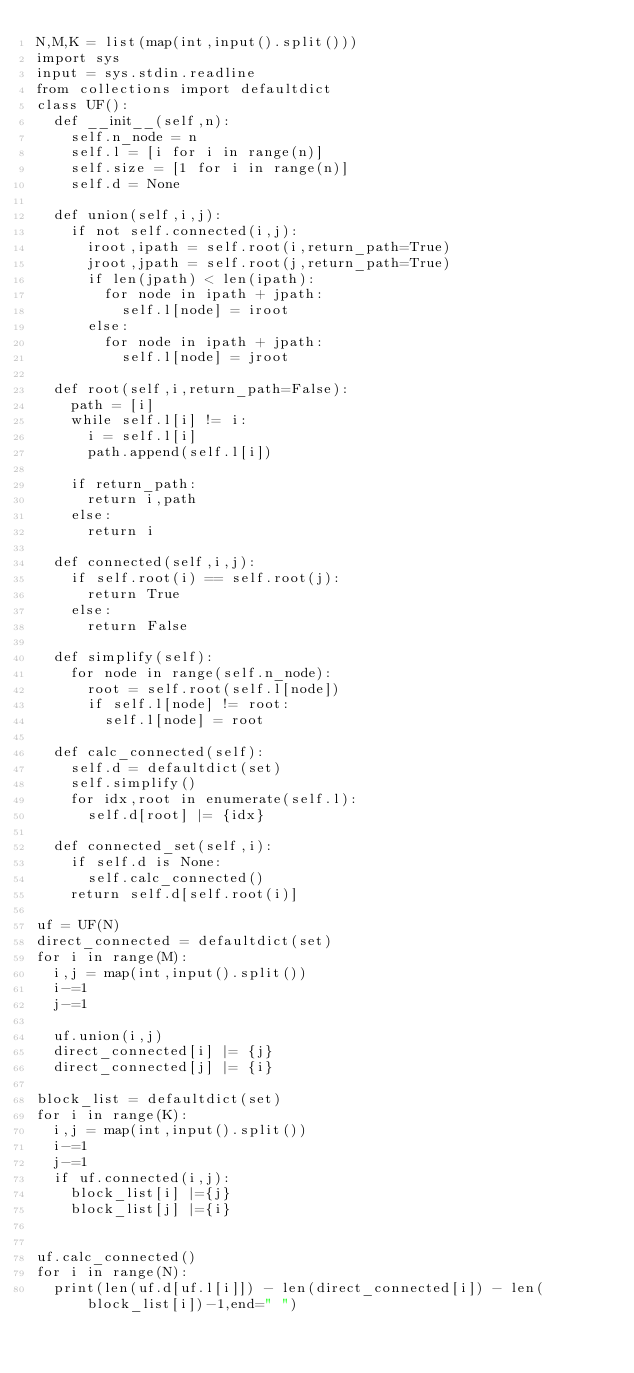<code> <loc_0><loc_0><loc_500><loc_500><_Python_>N,M,K = list(map(int,input().split()))
import sys
input = sys.stdin.readline
from collections import defaultdict
class UF():
  def __init__(self,n):
    self.n_node = n
    self.l = [i for i in range(n)]
    self.size = [1 for i in range(n)]
    self.d = None
  
  def union(self,i,j):
    if not self.connected(i,j):
      iroot,ipath = self.root(i,return_path=True)
      jroot,jpath = self.root(j,return_path=True)
      if len(jpath) < len(ipath):
        for node in ipath + jpath:
          self.l[node] = iroot
      else:
        for node in ipath + jpath:
          self.l[node] = jroot
        
  def root(self,i,return_path=False):
    path = [i]
    while self.l[i] != i:
      i = self.l[i]
      path.append(self.l[i])
    
    if return_path:
      return i,path
    else:
      return i
  
  def connected(self,i,j):
    if self.root(i) == self.root(j):
      return True
    else:
      return False
  
  def simplify(self):
    for node in range(self.n_node):
      root = self.root(self.l[node])
      if self.l[node] != root:
        self.l[node] = root
  
  def calc_connected(self):
    self.d = defaultdict(set)
    self.simplify()
    for idx,root in enumerate(self.l):
      self.d[root] |= {idx}
    
  def connected_set(self,i):
    if self.d is None:
      self.calc_connected()
    return self.d[self.root(i)]
      
uf = UF(N)
direct_connected = defaultdict(set)
for i in range(M):
  i,j = map(int,input().split())
  i-=1
  j-=1
  
  uf.union(i,j)
  direct_connected[i] |= {j}
  direct_connected[j] |= {i}

block_list = defaultdict(set)
for i in range(K):
  i,j = map(int,input().split())
  i-=1
  j-=1
  if uf.connected(i,j):
    block_list[i] |={j}
    block_list[j] |={i}

  
uf.calc_connected()
for i in range(N):
  print(len(uf.d[uf.l[i]]) - len(direct_connected[i]) - len(block_list[i])-1,end=" ")
</code> 